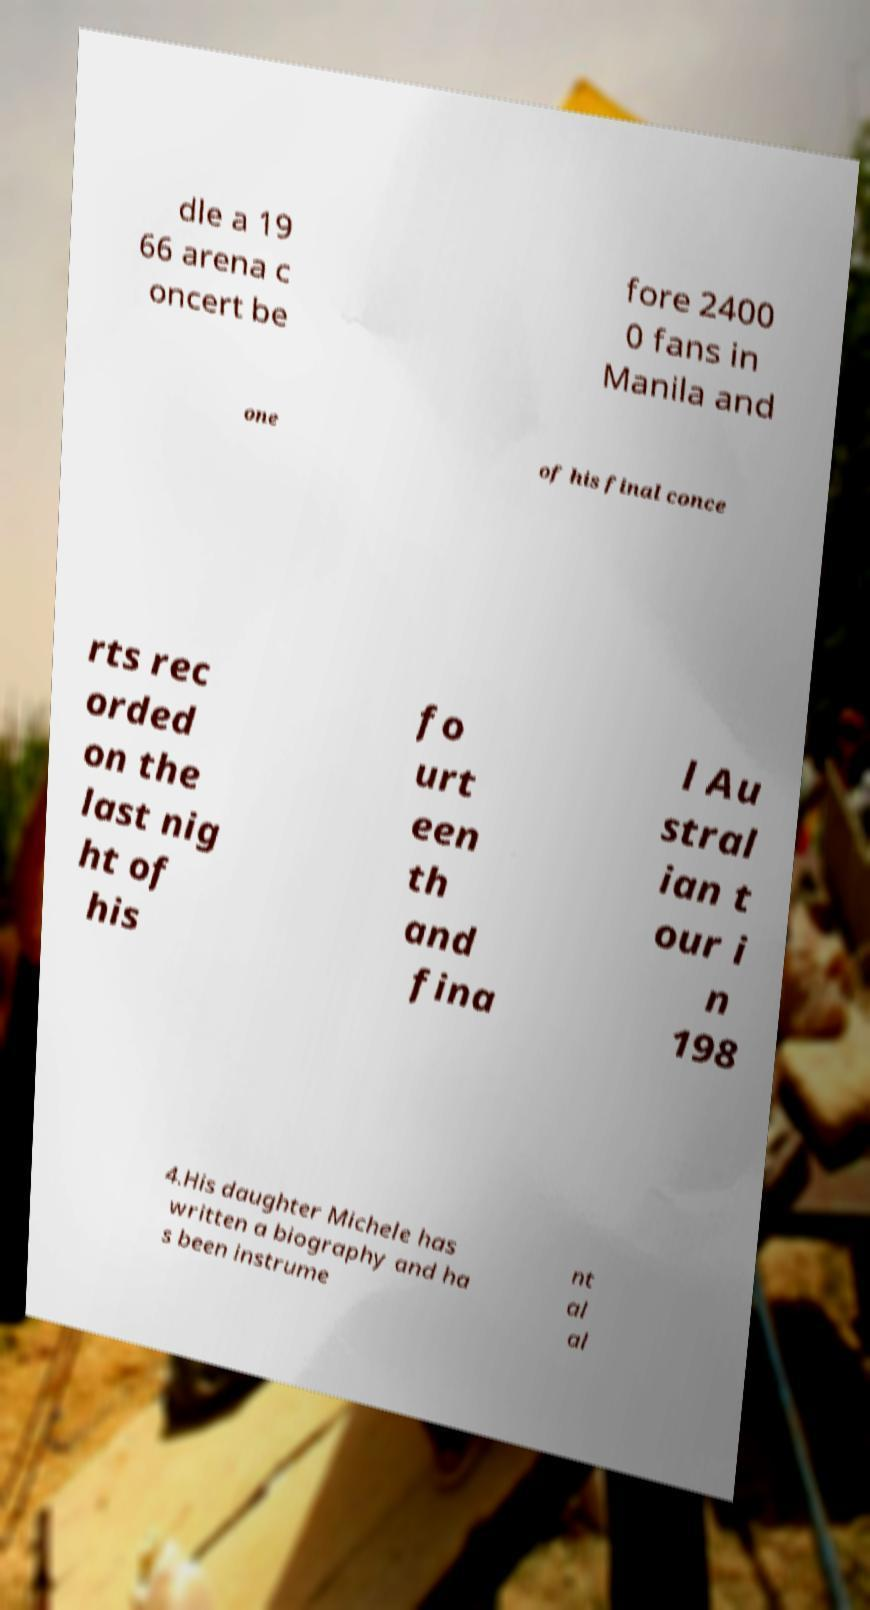There's text embedded in this image that I need extracted. Can you transcribe it verbatim? dle a 19 66 arena c oncert be fore 2400 0 fans in Manila and one of his final conce rts rec orded on the last nig ht of his fo urt een th and fina l Au stral ian t our i n 198 4.His daughter Michele has written a biography and ha s been instrume nt al al 